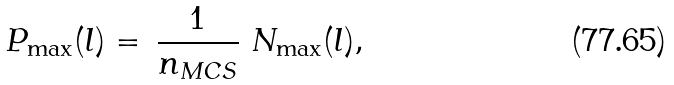Convert formula to latex. <formula><loc_0><loc_0><loc_500><loc_500>P _ { \max } ( l ) = \, \frac { 1 } { n _ { M C S } } \ N _ { \max } ( l ) ,</formula> 